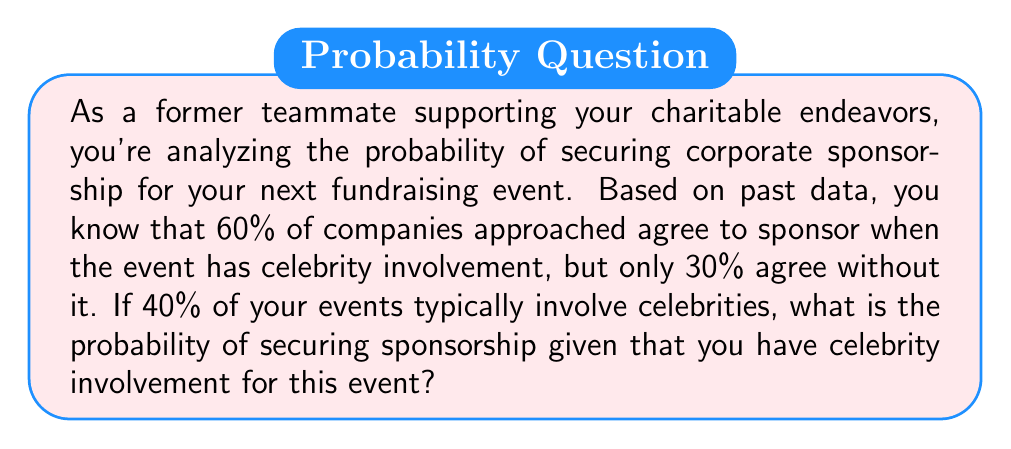Provide a solution to this math problem. Let's approach this step-by-step using Bayes' Theorem:

1) Define our events:
   A: Secure sponsorship
   B: Celebrity involvement

2) Given probabilities:
   P(B) = 0.40 (40% of events involve celebrities)
   P(A|B) = 0.60 (60% agree to sponsor with celebrity involvement)
   P(A|not B) = 0.30 (30% agree to sponsor without celebrity involvement)

3) We need to find P(A|B), which is given, but let's verify using Bayes' Theorem:

   $$P(A|B) = \frac{P(B|A) \cdot P(A)}{P(B)}$$

4) To use this, we need P(A), which we can calculate using the law of total probability:

   $$P(A) = P(A|B) \cdot P(B) + P(A|not B) \cdot P(not B)$$
   $$P(A) = 0.60 \cdot 0.40 + 0.30 \cdot 0.60 = 0.24 + 0.18 = 0.42$$

5) Now we can verify P(A|B):

   $$P(A|B) = \frac{P(B|A) \cdot P(A)}{P(B)} = \frac{0.60 \cdot 0.42}{0.40} = 0.60$$

This matches our given probability, confirming our calculations.

Therefore, the probability of securing sponsorship given celebrity involvement is 0.60 or 60%.
Answer: 0.60 